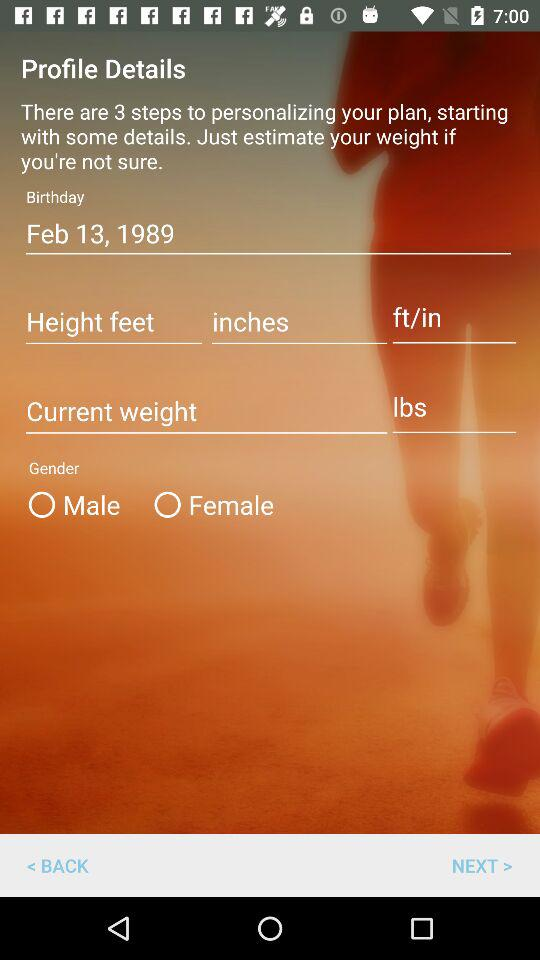What's the measurement unit of height? The measurement unit of height is feet and inches. 